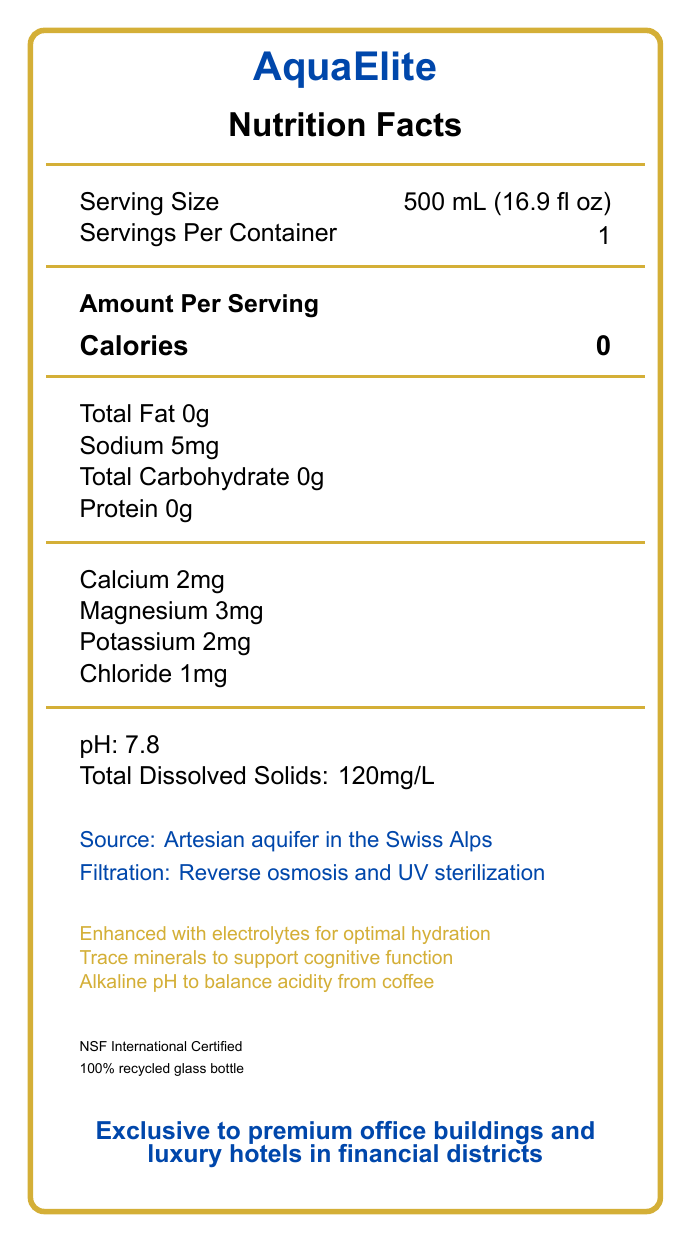what is the brand name of the bottled water? The brand name is prominently displayed at the top of the label in large, bold text.
Answer: AquaElite what is the serving size of AquaElite bottled water? The serving size is listed under the "Serving Size" section on the label.
Answer: 500 mL (16.9 fl oz) how many servings are there per container of AquaElite water? The "Servings Per Container" information is found right below the serving size.
Answer: 1 what is the amount of sodium in AquaElite water? The sodium content is mentioned under the nutritional information on the label.
Answer: 5mg how much protein is in a serving of AquaElite? The protein content is found in the nutritional details section, which lists it as 0g.
Answer: 0g what filtration process is used for AquaElite water? The filtration process details can be found at the bottom left of the label.
Answer: Reverse osmosis and UV sterilization Multiple-choice: what special feature is claimed to help balance acidity from coffee consumption in AquaElite water?
A. Enhanced with electrolytes
B. Trace minerals
C. Alkaline pH The label states that the "Alkaline pH to help balance acidity from coffee consumption."
Answer: C Multiple-choice: what is the price per bottle of AquaElite water?
i. $10.99
ii. $11.99
iii. $12.99
iv. $13.99 The price per bottle is listed as $12.99 on the label.
Answer: iii. $12.99 Is AquaElite water certified by NSF International? The label includes a note stating "NSF International Certified."
Answer: Yes describe the main idea of the AquaElite nutrition facts label. The label summarizes various attributes of the water, including its nutritional value (e.g., zero calories, low sodium), beneficial additives (e.g., electrolytes and minerals), and unique selling points (e.g., artesian source, luxury packaging, and sustainability efforts).
Answer: The AquaElite nutrition facts label provides details on serving size, nutritional content per serving, mineral content, source and filtration process, certification, and special features of the luxury bottled water. It highlights its enhanced electrolytes, trace minerals, alkaline pH for balancing acidity, and emphasizes sustainability and exclusive availability. what is the total dissolved solids content in AquaElite water? The total dissolved solids content is mentioned towards the bottom in the nutritional information.
Answer: 120mg/L where is the source of AquaElite water? The source of the water is provided in the detailed information section at the bottom of the label.
Answer: Artesian aquifer in the Swiss Alps what material is used for AquaElite water bottles? The label mentions that the bottle is made of 100% recycled glass.
Answer: 100% recycled glass what sustainability practices does AquaElite follow? The label states that AquaElite is committed to reducing its carbon footprint through these practices.
Answer: Carbon-neutral shipping and 100% renewable energy in production which of the following minerals is *not* listed on the AquaElite label?
A. Sodium
B. Zinc
C. Magnesium
D. Potassium Zinc is not listed on the label, while sodium, magnesium, and potassium are.
Answer: B can it be determined from the label how many bottles are in a pack? The label does not provide any details about the packaging quantity, such as how many bottles are in a pack.
Answer: Not enough information 